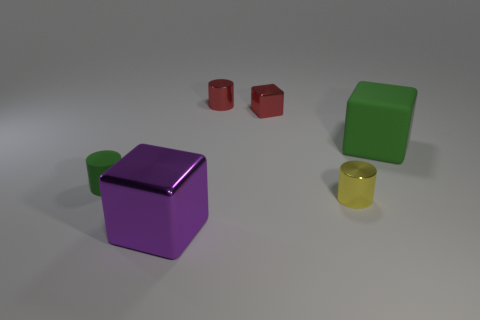Is the big matte thing the same color as the small rubber object?
Provide a short and direct response. Yes. The cylinder that is the same color as the tiny metal block is what size?
Your answer should be compact. Small. There is a purple object that is the same material as the small red cube; what is its size?
Offer a terse response. Large. Do the green thing right of the purple metal cube and the metal block in front of the red cube have the same size?
Offer a terse response. Yes. What number of things are large cyan cylinders or big green rubber blocks?
Make the answer very short. 1. The tiny yellow metallic thing has what shape?
Your answer should be very brief. Cylinder. What is the size of the other metallic object that is the same shape as the large purple object?
Provide a short and direct response. Small. There is a thing behind the metal block to the right of the purple metal thing; how big is it?
Provide a short and direct response. Small. Are there an equal number of big metal things right of the big shiny block and cyan metallic spheres?
Offer a very short reply. Yes. How many other objects are there of the same color as the big metal cube?
Give a very brief answer. 0. 